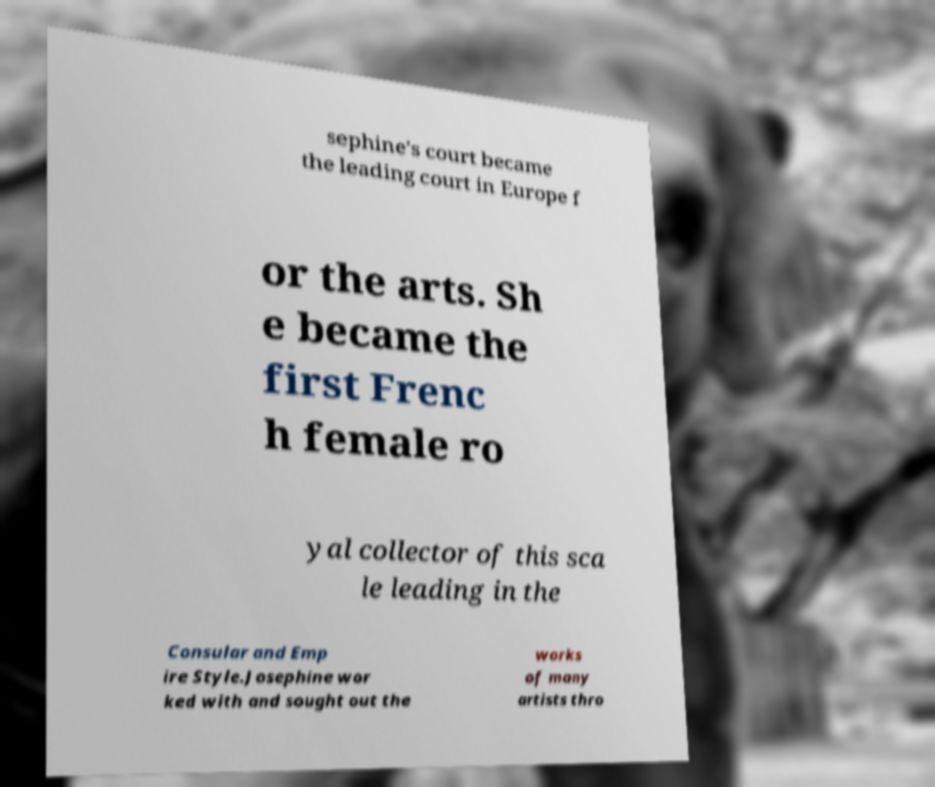What messages or text are displayed in this image? I need them in a readable, typed format. sephine's court became the leading court in Europe f or the arts. Sh e became the first Frenc h female ro yal collector of this sca le leading in the Consular and Emp ire Style.Josephine wor ked with and sought out the works of many artists thro 